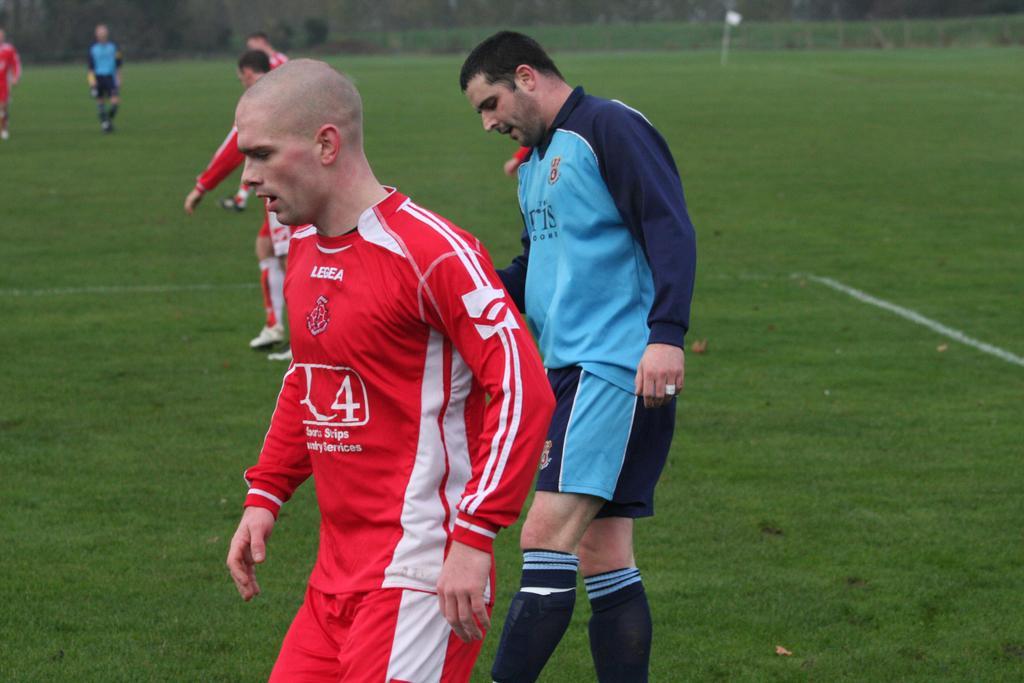Describe this image in one or two sentences. There are a group of players walking on the ground, they are wearing blue dress and red dress. 